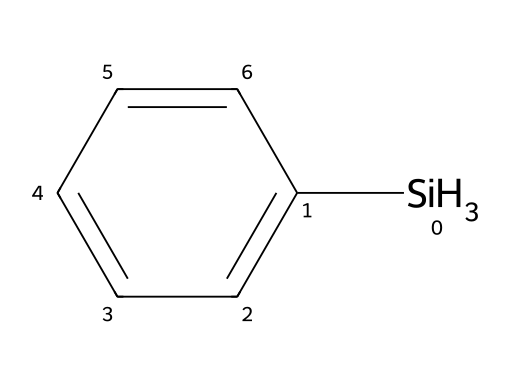What is the name of this chemical? The SMILES representation includes the pattern [SiH3] bonded to a phenyl group (c1ccccc1), which indicates it is phenylsilane.
Answer: phenylsilane How many hydrogen atoms are in phenylsilane? The [SiH3] indicates there are three hydrogen atoms directly attached to silicon, and the phenyl group (c1ccccc1) has five hydrogen atoms attached, totaling eight hydrogen atoms.
Answer: eight What type of chemical bond is primarily present in phenylsilane? The chemical structure features covalent bonds, particularly between the silicon and hydrogen atoms as well as between the phenyl carbon atoms.
Answer: covalent What is the hybridization of the silicon atom in phenylsilane? Silicon in phenylsilane is bonded to three hydrogen atoms and one phenyl ring, leading to a tetrahedral geometry, indicating sp3 hybridization.
Answer: sp3 How does the presence of the phenyl group affect the reactivity of phenylsilane compared to other silanes? The phenyl group is electron-withdrawing due to resonance, which usually decreases the reactivity of silanes compared to those with more electron-donating groups.
Answer: decreases What is the molecular formula of phenylsilane? Connecting the components from the SMILES, the phenyl group contributes C6H5, silicon adds Si, and there are 3 more hydrogens from [SiH3], giving the formula C6H9Si.
Answer: C6H9Si 